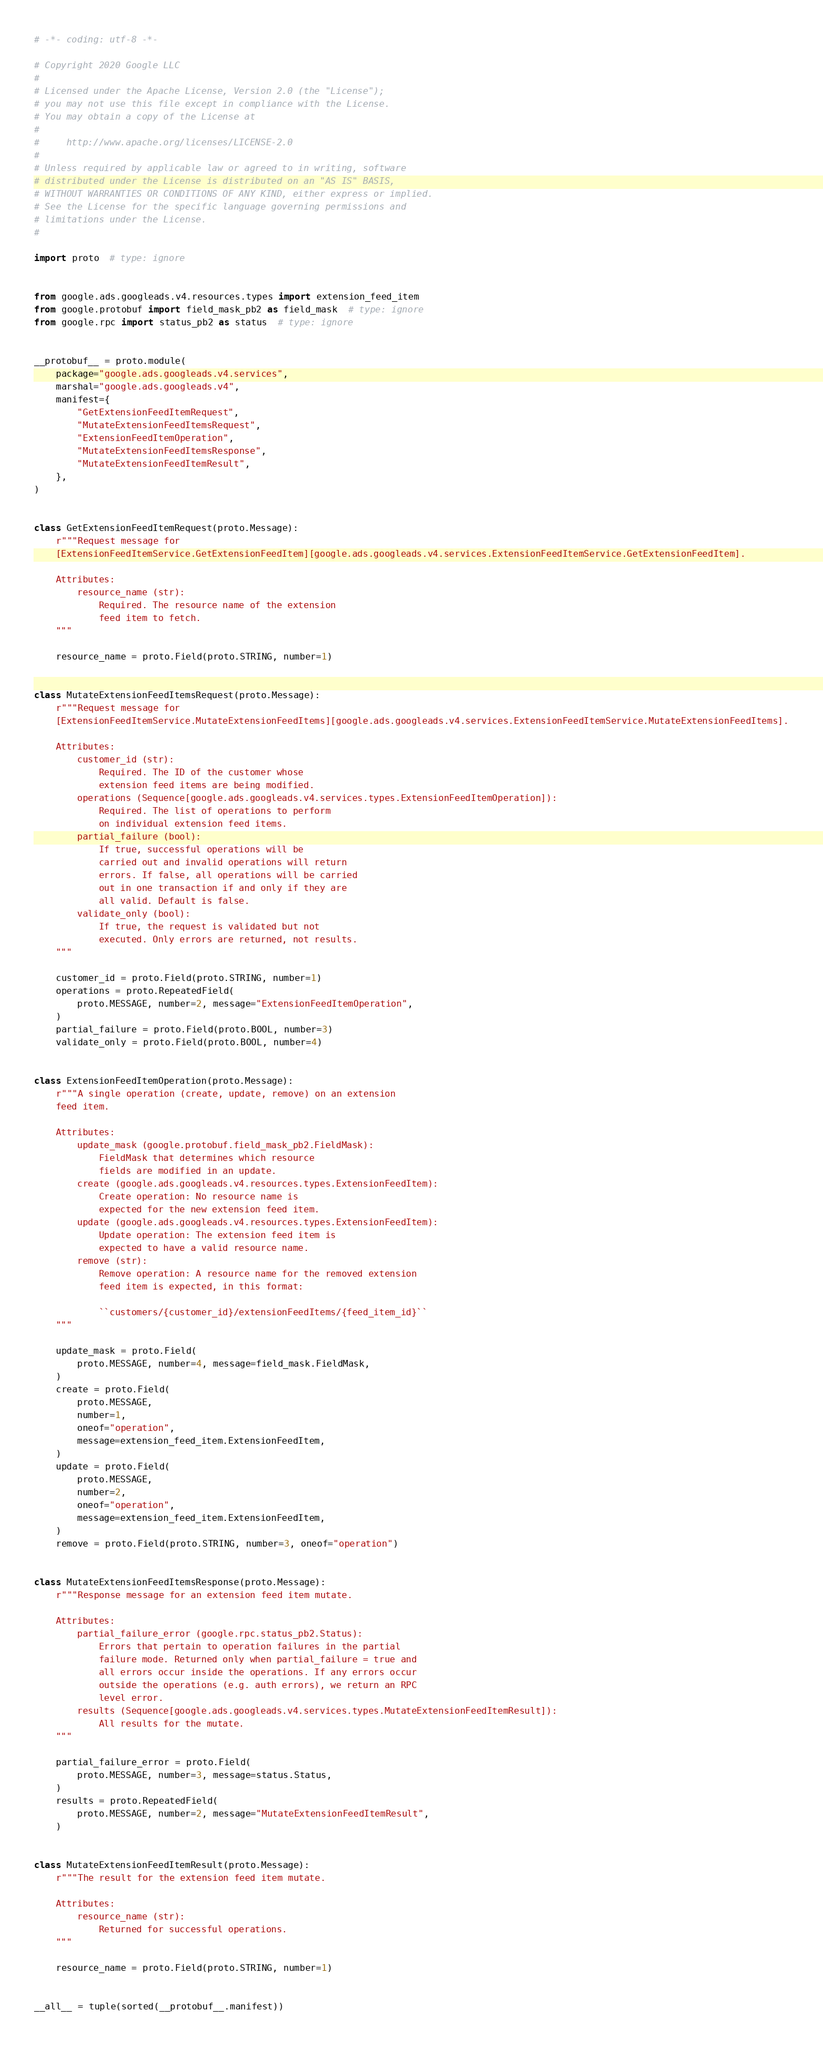Convert code to text. <code><loc_0><loc_0><loc_500><loc_500><_Python_># -*- coding: utf-8 -*-

# Copyright 2020 Google LLC
#
# Licensed under the Apache License, Version 2.0 (the "License");
# you may not use this file except in compliance with the License.
# You may obtain a copy of the License at
#
#     http://www.apache.org/licenses/LICENSE-2.0
#
# Unless required by applicable law or agreed to in writing, software
# distributed under the License is distributed on an "AS IS" BASIS,
# WITHOUT WARRANTIES OR CONDITIONS OF ANY KIND, either express or implied.
# See the License for the specific language governing permissions and
# limitations under the License.
#

import proto  # type: ignore


from google.ads.googleads.v4.resources.types import extension_feed_item
from google.protobuf import field_mask_pb2 as field_mask  # type: ignore
from google.rpc import status_pb2 as status  # type: ignore


__protobuf__ = proto.module(
    package="google.ads.googleads.v4.services",
    marshal="google.ads.googleads.v4",
    manifest={
        "GetExtensionFeedItemRequest",
        "MutateExtensionFeedItemsRequest",
        "ExtensionFeedItemOperation",
        "MutateExtensionFeedItemsResponse",
        "MutateExtensionFeedItemResult",
    },
)


class GetExtensionFeedItemRequest(proto.Message):
    r"""Request message for
    [ExtensionFeedItemService.GetExtensionFeedItem][google.ads.googleads.v4.services.ExtensionFeedItemService.GetExtensionFeedItem].

    Attributes:
        resource_name (str):
            Required. The resource name of the extension
            feed item to fetch.
    """

    resource_name = proto.Field(proto.STRING, number=1)


class MutateExtensionFeedItemsRequest(proto.Message):
    r"""Request message for
    [ExtensionFeedItemService.MutateExtensionFeedItems][google.ads.googleads.v4.services.ExtensionFeedItemService.MutateExtensionFeedItems].

    Attributes:
        customer_id (str):
            Required. The ID of the customer whose
            extension feed items are being modified.
        operations (Sequence[google.ads.googleads.v4.services.types.ExtensionFeedItemOperation]):
            Required. The list of operations to perform
            on individual extension feed items.
        partial_failure (bool):
            If true, successful operations will be
            carried out and invalid operations will return
            errors. If false, all operations will be carried
            out in one transaction if and only if they are
            all valid. Default is false.
        validate_only (bool):
            If true, the request is validated but not
            executed. Only errors are returned, not results.
    """

    customer_id = proto.Field(proto.STRING, number=1)
    operations = proto.RepeatedField(
        proto.MESSAGE, number=2, message="ExtensionFeedItemOperation",
    )
    partial_failure = proto.Field(proto.BOOL, number=3)
    validate_only = proto.Field(proto.BOOL, number=4)


class ExtensionFeedItemOperation(proto.Message):
    r"""A single operation (create, update, remove) on an extension
    feed item.

    Attributes:
        update_mask (google.protobuf.field_mask_pb2.FieldMask):
            FieldMask that determines which resource
            fields are modified in an update.
        create (google.ads.googleads.v4.resources.types.ExtensionFeedItem):
            Create operation: No resource name is
            expected for the new extension feed item.
        update (google.ads.googleads.v4.resources.types.ExtensionFeedItem):
            Update operation: The extension feed item is
            expected to have a valid resource name.
        remove (str):
            Remove operation: A resource name for the removed extension
            feed item is expected, in this format:

            ``customers/{customer_id}/extensionFeedItems/{feed_item_id}``
    """

    update_mask = proto.Field(
        proto.MESSAGE, number=4, message=field_mask.FieldMask,
    )
    create = proto.Field(
        proto.MESSAGE,
        number=1,
        oneof="operation",
        message=extension_feed_item.ExtensionFeedItem,
    )
    update = proto.Field(
        proto.MESSAGE,
        number=2,
        oneof="operation",
        message=extension_feed_item.ExtensionFeedItem,
    )
    remove = proto.Field(proto.STRING, number=3, oneof="operation")


class MutateExtensionFeedItemsResponse(proto.Message):
    r"""Response message for an extension feed item mutate.

    Attributes:
        partial_failure_error (google.rpc.status_pb2.Status):
            Errors that pertain to operation failures in the partial
            failure mode. Returned only when partial_failure = true and
            all errors occur inside the operations. If any errors occur
            outside the operations (e.g. auth errors), we return an RPC
            level error.
        results (Sequence[google.ads.googleads.v4.services.types.MutateExtensionFeedItemResult]):
            All results for the mutate.
    """

    partial_failure_error = proto.Field(
        proto.MESSAGE, number=3, message=status.Status,
    )
    results = proto.RepeatedField(
        proto.MESSAGE, number=2, message="MutateExtensionFeedItemResult",
    )


class MutateExtensionFeedItemResult(proto.Message):
    r"""The result for the extension feed item mutate.

    Attributes:
        resource_name (str):
            Returned for successful operations.
    """

    resource_name = proto.Field(proto.STRING, number=1)


__all__ = tuple(sorted(__protobuf__.manifest))
</code> 